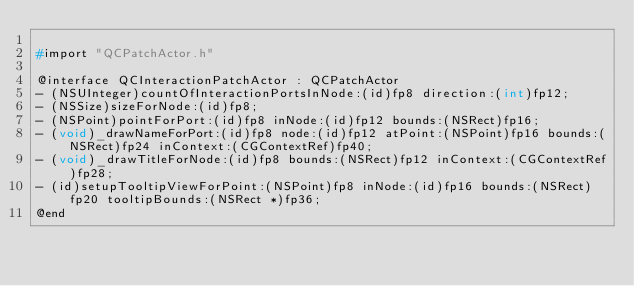<code> <loc_0><loc_0><loc_500><loc_500><_C_>
#import "QCPatchActor.h"

@interface QCInteractionPatchActor : QCPatchActor
- (NSUInteger)countOfInteractionPortsInNode:(id)fp8 direction:(int)fp12;
- (NSSize)sizeForNode:(id)fp8;
- (NSPoint)pointForPort:(id)fp8 inNode:(id)fp12 bounds:(NSRect)fp16;
- (void)_drawNameForPort:(id)fp8 node:(id)fp12 atPoint:(NSPoint)fp16 bounds:(NSRect)fp24 inContext:(CGContextRef)fp40;
- (void)_drawTitleForNode:(id)fp8 bounds:(NSRect)fp12 inContext:(CGContextRef)fp28;
- (id)setupTooltipViewForPoint:(NSPoint)fp8 inNode:(id)fp16 bounds:(NSRect)fp20 tooltipBounds:(NSRect *)fp36;
@end
</code> 